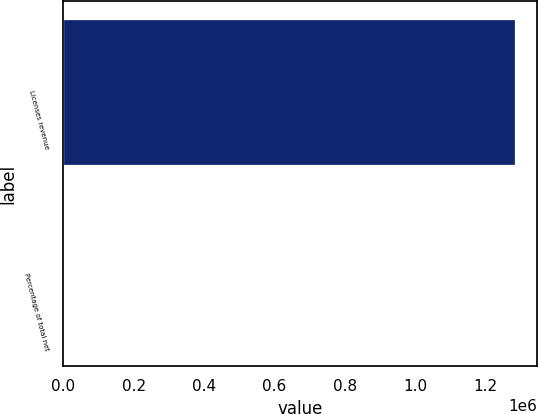<chart> <loc_0><loc_0><loc_500><loc_500><bar_chart><fcel>Licenses revenue<fcel>Percentage of total net<nl><fcel>1.28179e+06<fcel>25<nl></chart> 